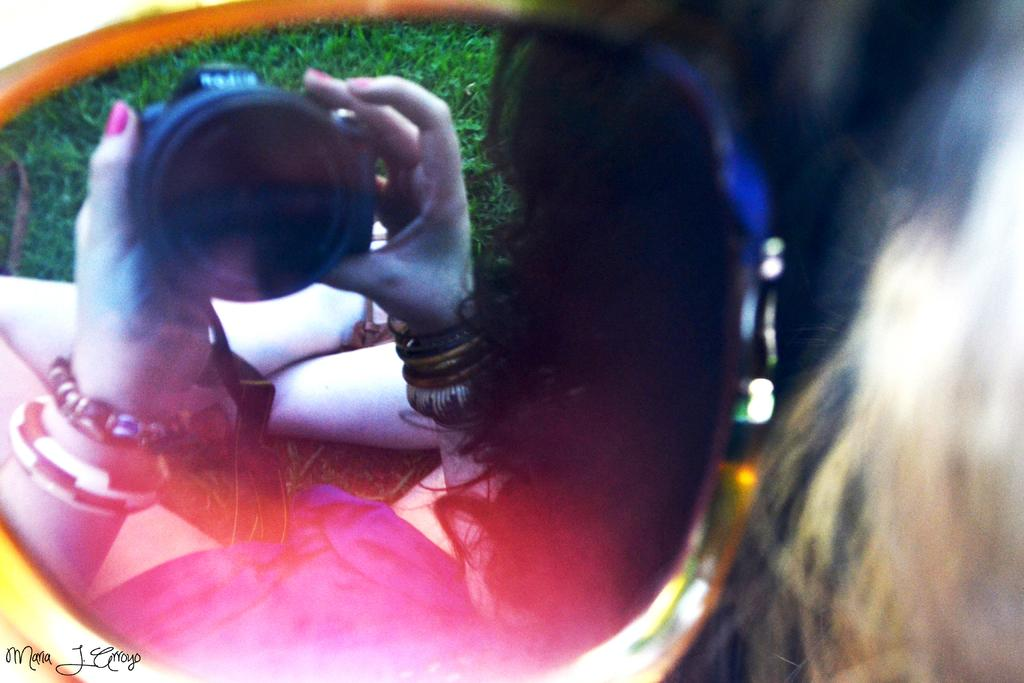Who is present in the image? There is a person in the image. What is the person doing in the image? The person is sitting on the grass land. What object is the person holding in the image? The person is holding a camera. Can you describe any unique features of the image? There is a reflection of the person in the image. What type of chicken can be seen in the image? There is no chicken present in the image. Is there a flame visible in the image? No, there is no flame visible in the image. 